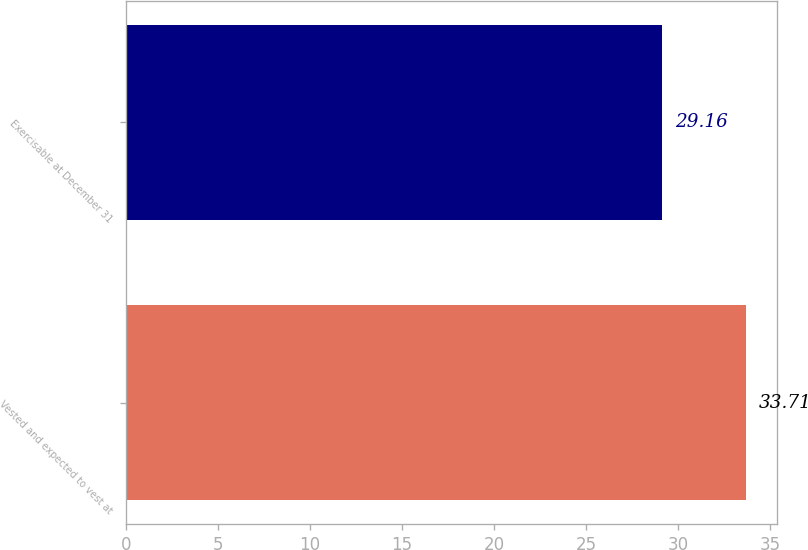Convert chart to OTSL. <chart><loc_0><loc_0><loc_500><loc_500><bar_chart><fcel>Vested and expected to vest at<fcel>Exercisable at December 31<nl><fcel>33.71<fcel>29.16<nl></chart> 